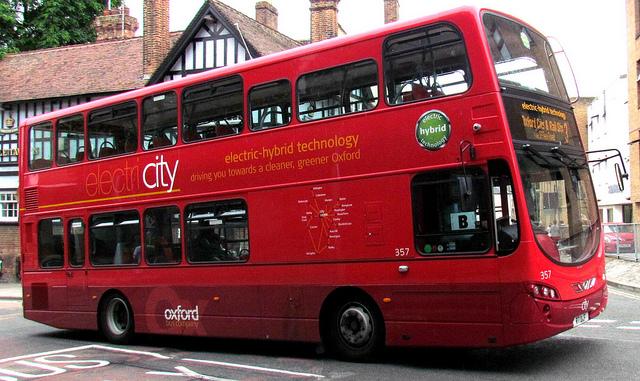What is the number on the bus?
Quick response, please. 357. What color is the bus?
Write a very short answer. Red. Is the bus a double-decker?
Give a very brief answer. Yes. 